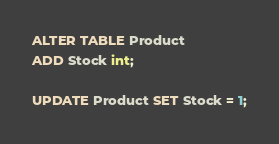<code> <loc_0><loc_0><loc_500><loc_500><_SQL_>ALTER TABLE Product
ADD Stock int;

UPDATE Product SET Stock = 1;

</code> 